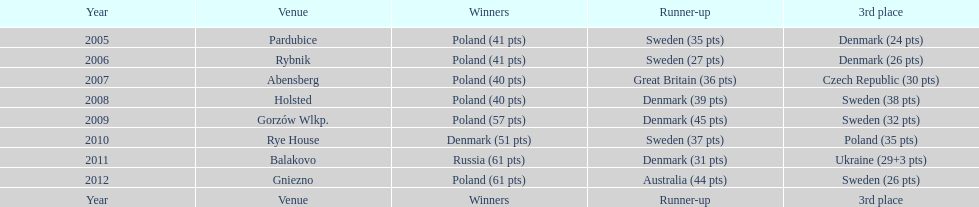What was the distinction in the final score between russia and denmark in 2011? 30. Parse the full table. {'header': ['Year', 'Venue', 'Winners', 'Runner-up', '3rd place'], 'rows': [['2005', 'Pardubice', 'Poland (41 pts)', 'Sweden (35 pts)', 'Denmark (24 pts)'], ['2006', 'Rybnik', 'Poland (41 pts)', 'Sweden (27 pts)', 'Denmark (26 pts)'], ['2007', 'Abensberg', 'Poland (40 pts)', 'Great Britain (36 pts)', 'Czech Republic (30 pts)'], ['2008', 'Holsted', 'Poland (40 pts)', 'Denmark (39 pts)', 'Sweden (38 pts)'], ['2009', 'Gorzów Wlkp.', 'Poland (57 pts)', 'Denmark (45 pts)', 'Sweden (32 pts)'], ['2010', 'Rye House', 'Denmark (51 pts)', 'Sweden (37 pts)', 'Poland (35 pts)'], ['2011', 'Balakovo', 'Russia (61 pts)', 'Denmark (31 pts)', 'Ukraine (29+3 pts)'], ['2012', 'Gniezno', 'Poland (61 pts)', 'Australia (44 pts)', 'Sweden (26 pts)'], ['Year', 'Venue', 'Winners', 'Runner-up', '3rd place']]} 